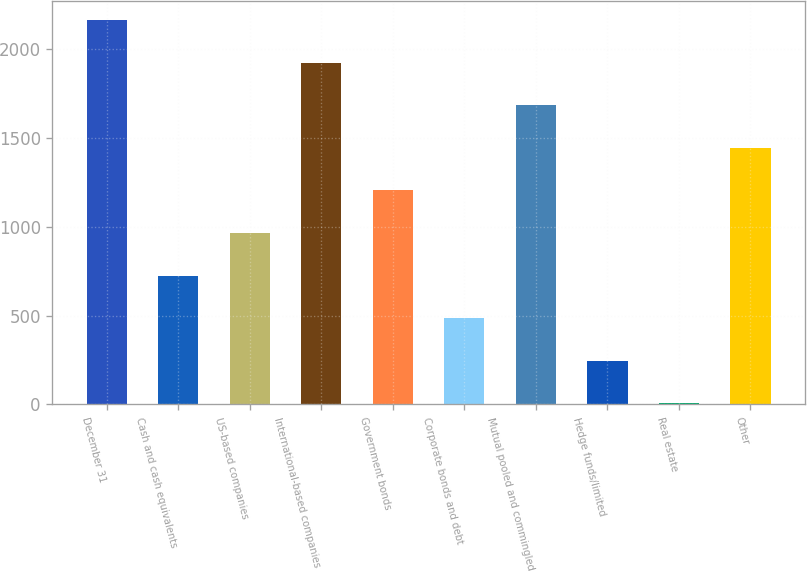Convert chart to OTSL. <chart><loc_0><loc_0><loc_500><loc_500><bar_chart><fcel>December 31<fcel>Cash and cash equivalents<fcel>US-based companies<fcel>International-based companies<fcel>Government bonds<fcel>Corporate bonds and debt<fcel>Mutual pooled and commingled<fcel>Hedge funds/limited<fcel>Real estate<fcel>Other<nl><fcel>2163.3<fcel>725.1<fcel>964.8<fcel>1923.6<fcel>1204.5<fcel>485.4<fcel>1683.9<fcel>245.7<fcel>6<fcel>1444.2<nl></chart> 